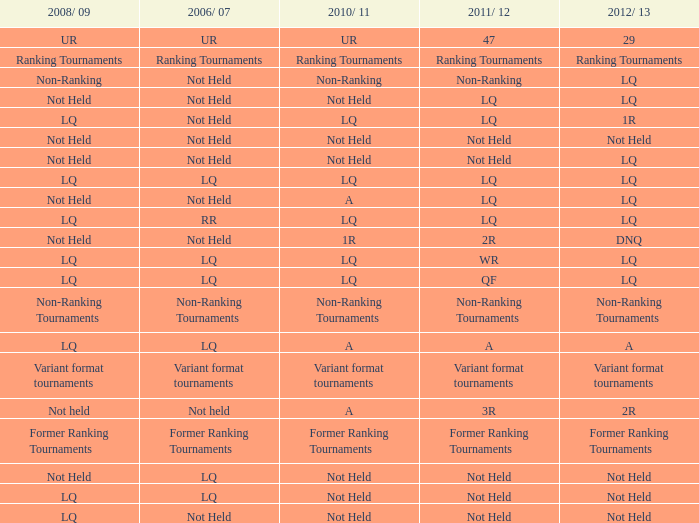Give me the full table as a dictionary. {'header': ['2008/ 09', '2006/ 07', '2010/ 11', '2011/ 12', '2012/ 13'], 'rows': [['UR', 'UR', 'UR', '47', '29'], ['Ranking Tournaments', 'Ranking Tournaments', 'Ranking Tournaments', 'Ranking Tournaments', 'Ranking Tournaments'], ['Non-Ranking', 'Not Held', 'Non-Ranking', 'Non-Ranking', 'LQ'], ['Not Held', 'Not Held', 'Not Held', 'LQ', 'LQ'], ['LQ', 'Not Held', 'LQ', 'LQ', '1R'], ['Not Held', 'Not Held', 'Not Held', 'Not Held', 'Not Held'], ['Not Held', 'Not Held', 'Not Held', 'Not Held', 'LQ'], ['LQ', 'LQ', 'LQ', 'LQ', 'LQ'], ['Not Held', 'Not Held', 'A', 'LQ', 'LQ'], ['LQ', 'RR', 'LQ', 'LQ', 'LQ'], ['Not Held', 'Not Held', '1R', '2R', 'DNQ'], ['LQ', 'LQ', 'LQ', 'WR', 'LQ'], ['LQ', 'LQ', 'LQ', 'QF', 'LQ'], ['Non-Ranking Tournaments', 'Non-Ranking Tournaments', 'Non-Ranking Tournaments', 'Non-Ranking Tournaments', 'Non-Ranking Tournaments'], ['LQ', 'LQ', 'A', 'A', 'A'], ['Variant format tournaments', 'Variant format tournaments', 'Variant format tournaments', 'Variant format tournaments', 'Variant format tournaments'], ['Not held', 'Not held', 'A', '3R', '2R'], ['Former Ranking Tournaments', 'Former Ranking Tournaments', 'Former Ranking Tournaments', 'Former Ranking Tournaments', 'Former Ranking Tournaments'], ['Not Held', 'LQ', 'Not Held', 'Not Held', 'Not Held'], ['LQ', 'LQ', 'Not Held', 'Not Held', 'Not Held'], ['LQ', 'Not Held', 'Not Held', 'Not Held', 'Not Held']]} What is 2006/07, when 2008/09 is LQ, when 2012/13 is LQ, and when 2011/12 is WR? LQ. 